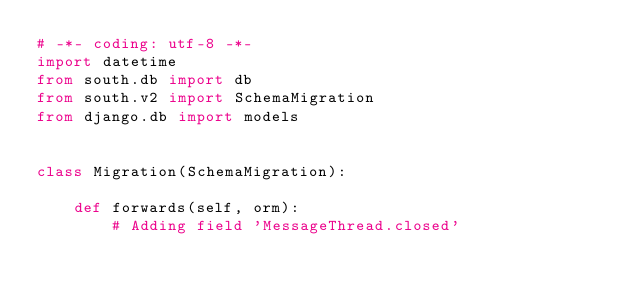Convert code to text. <code><loc_0><loc_0><loc_500><loc_500><_Python_># -*- coding: utf-8 -*-
import datetime
from south.db import db
from south.v2 import SchemaMigration
from django.db import models


class Migration(SchemaMigration):

    def forwards(self, orm):
        # Adding field 'MessageThread.closed'</code> 